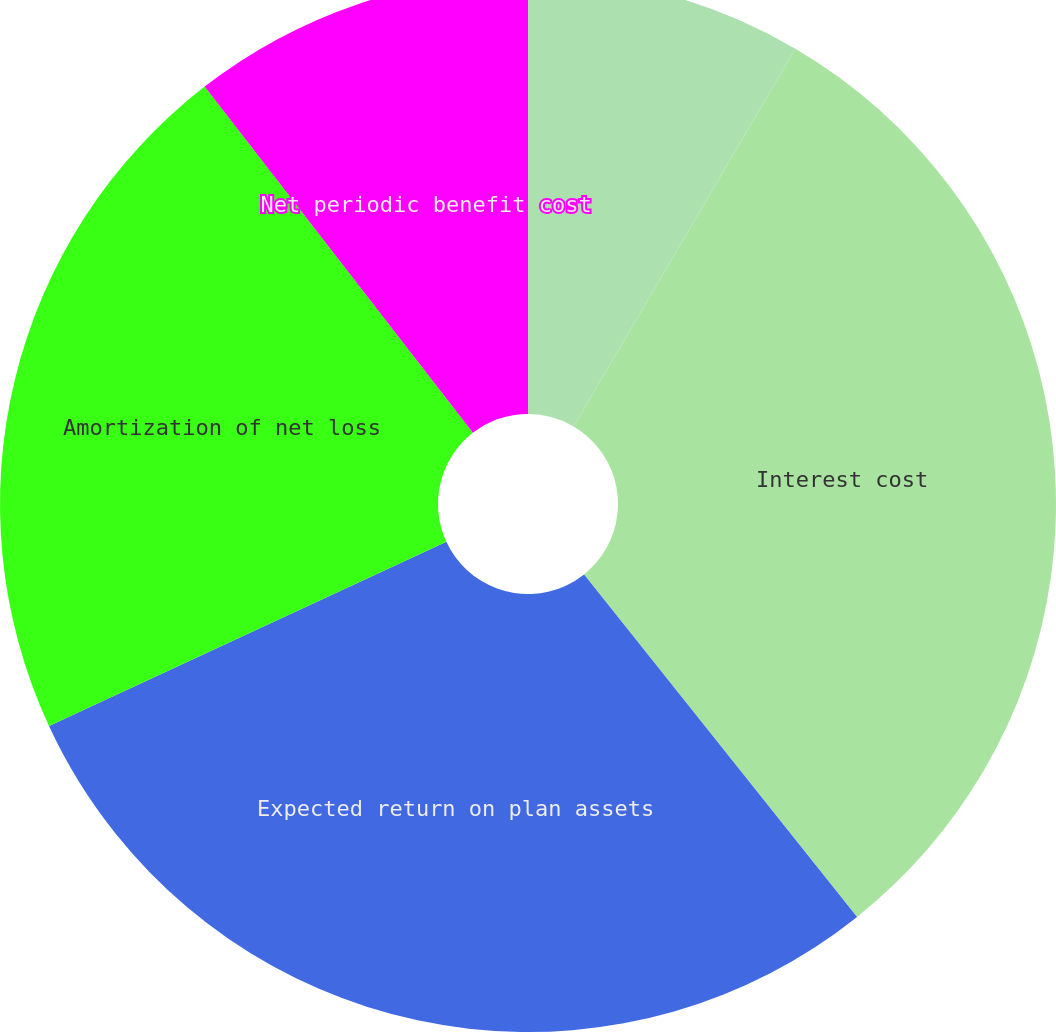Convert chart to OTSL. <chart><loc_0><loc_0><loc_500><loc_500><pie_chart><fcel>Service cost<fcel>Interest cost<fcel>Expected return on plan assets<fcel>Amortization of net loss<fcel>Net periodic benefit cost<nl><fcel>8.45%<fcel>30.84%<fcel>28.8%<fcel>21.42%<fcel>10.49%<nl></chart> 